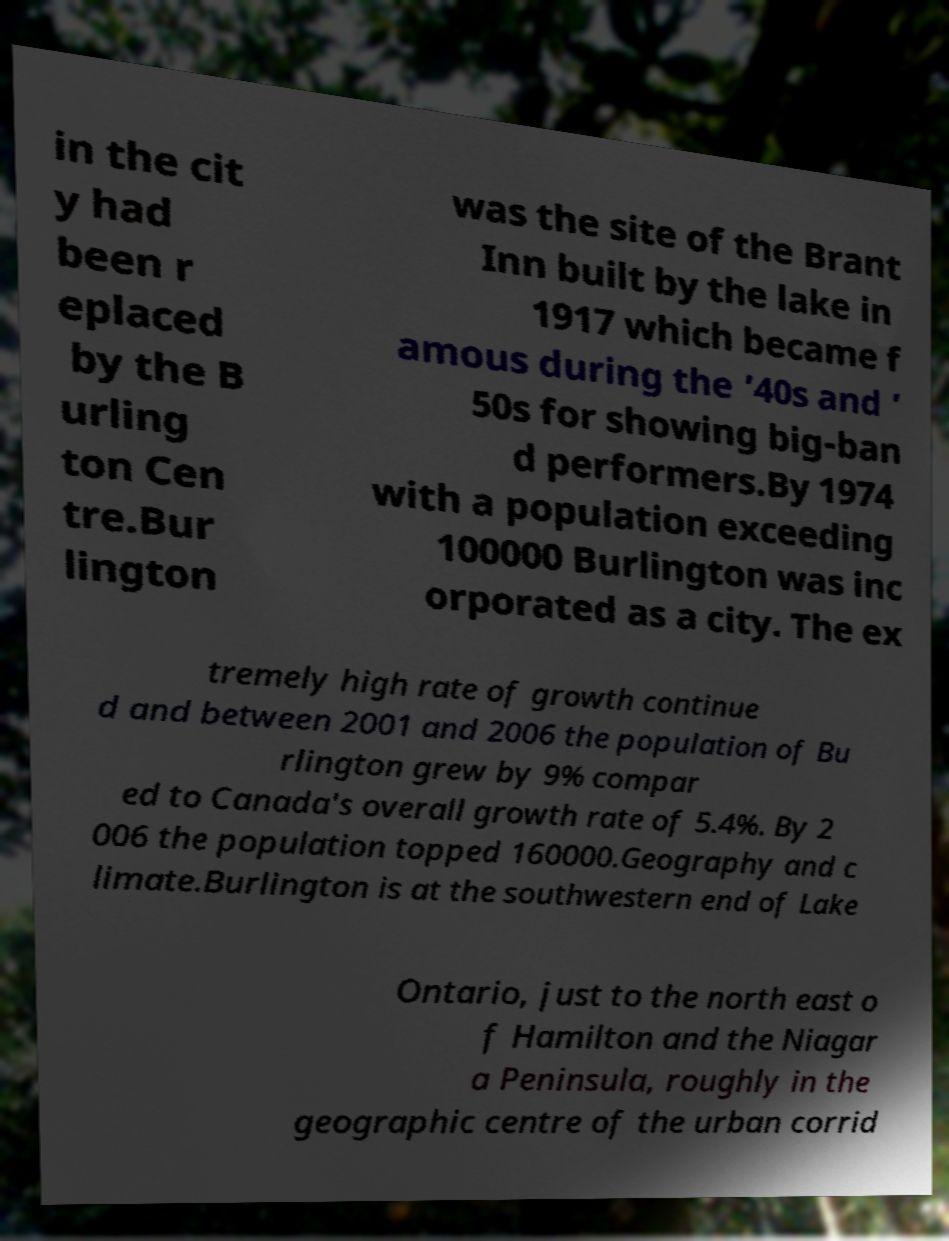Could you assist in decoding the text presented in this image and type it out clearly? in the cit y had been r eplaced by the B urling ton Cen tre.Bur lington was the site of the Brant Inn built by the lake in 1917 which became f amous during the ’40s and ’ 50s for showing big-ban d performers.By 1974 with a population exceeding 100000 Burlington was inc orporated as a city. The ex tremely high rate of growth continue d and between 2001 and 2006 the population of Bu rlington grew by 9% compar ed to Canada's overall growth rate of 5.4%. By 2 006 the population topped 160000.Geography and c limate.Burlington is at the southwestern end of Lake Ontario, just to the north east o f Hamilton and the Niagar a Peninsula, roughly in the geographic centre of the urban corrid 